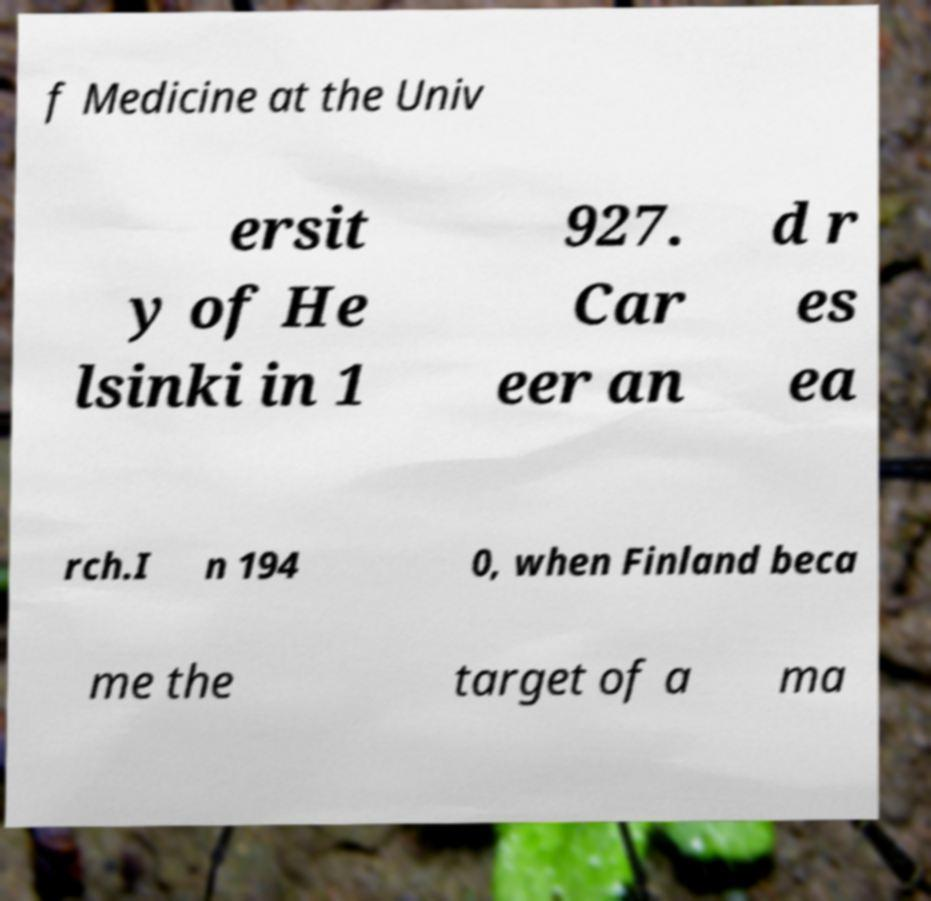Please read and relay the text visible in this image. What does it say? f Medicine at the Univ ersit y of He lsinki in 1 927. Car eer an d r es ea rch.I n 194 0, when Finland beca me the target of a ma 